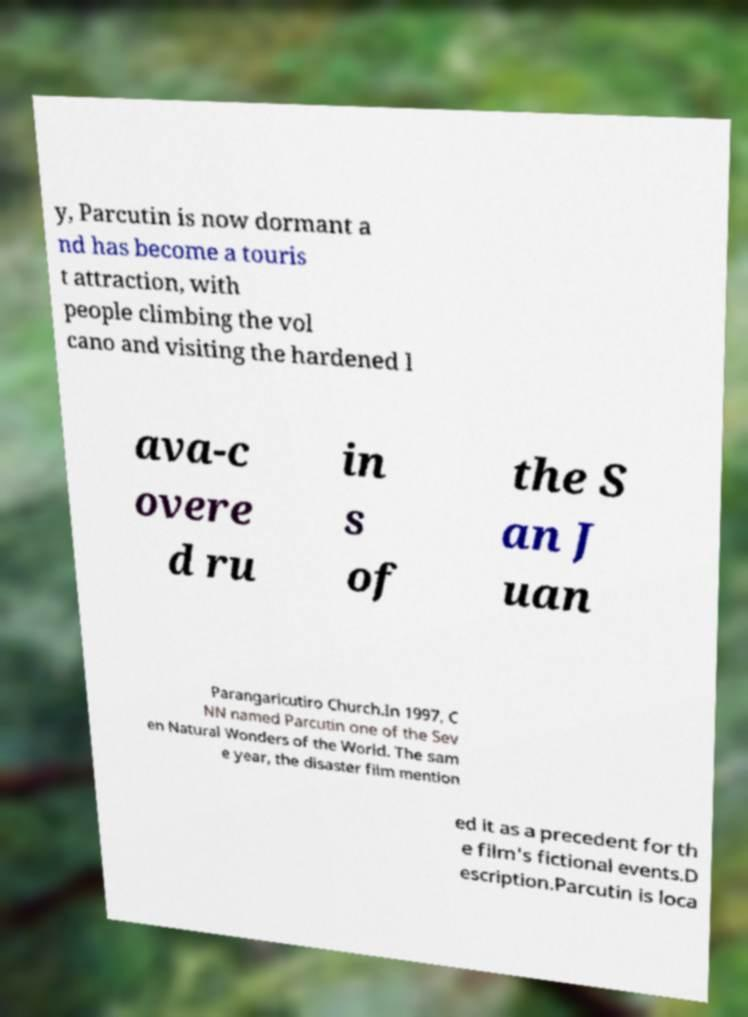Please identify and transcribe the text found in this image. y, Parcutin is now dormant a nd has become a touris t attraction, with people climbing the vol cano and visiting the hardened l ava-c overe d ru in s of the S an J uan Parangaricutiro Church.In 1997, C NN named Parcutin one of the Sev en Natural Wonders of the World. The sam e year, the disaster film mention ed it as a precedent for th e film's fictional events.D escription.Parcutin is loca 